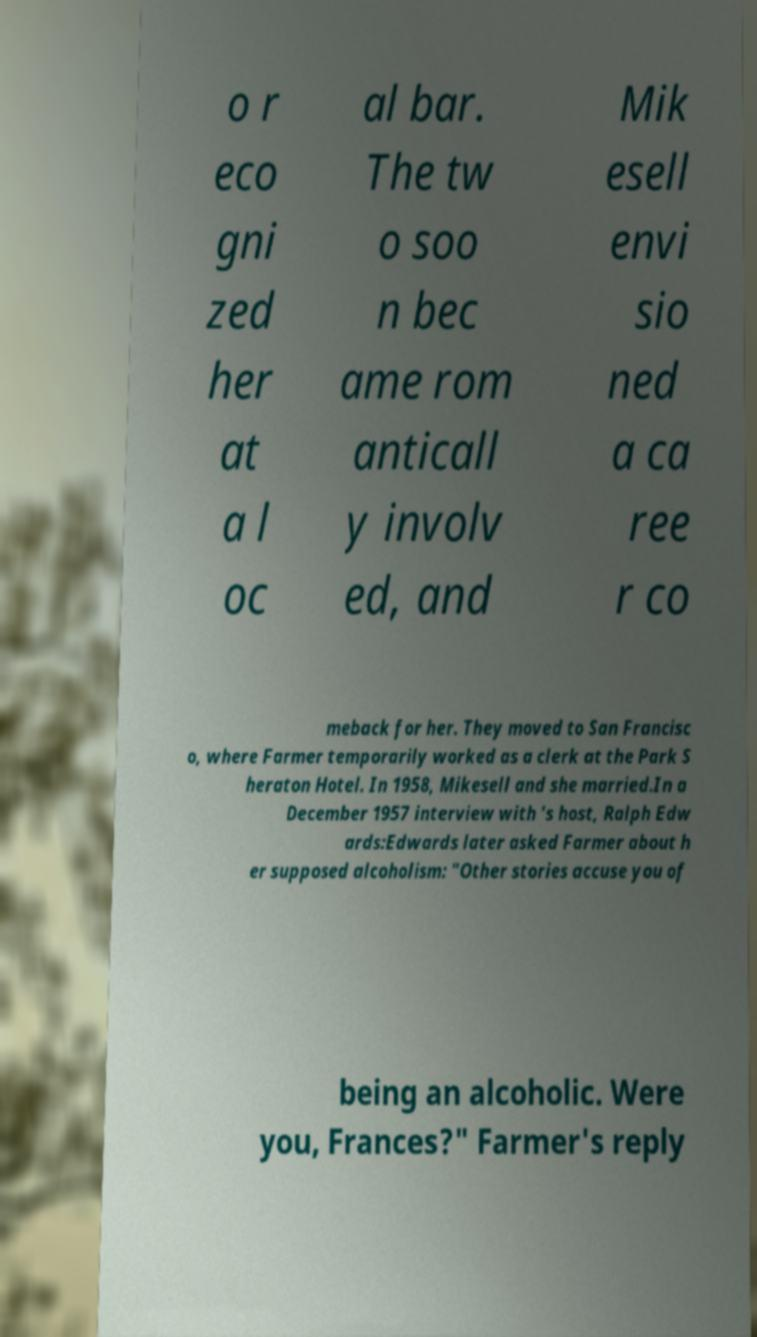Please read and relay the text visible in this image. What does it say? o r eco gni zed her at a l oc al bar. The tw o soo n bec ame rom anticall y involv ed, and Mik esell envi sio ned a ca ree r co meback for her. They moved to San Francisc o, where Farmer temporarily worked as a clerk at the Park S heraton Hotel. In 1958, Mikesell and she married.In a December 1957 interview with 's host, Ralph Edw ards:Edwards later asked Farmer about h er supposed alcoholism: "Other stories accuse you of being an alcoholic. Were you, Frances?" Farmer's reply 